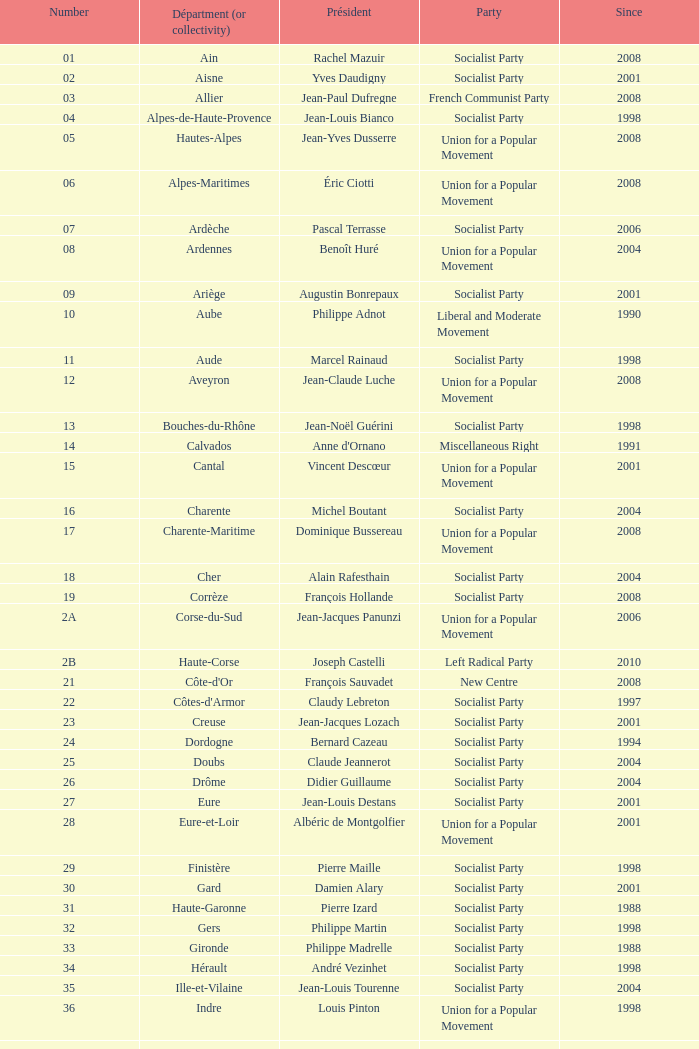What number corresponds to Presidet Yves Krattinger of the Socialist party? 70.0. 